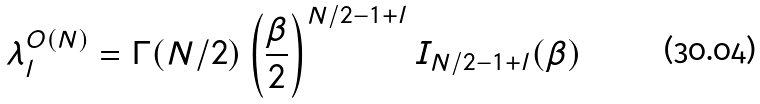<formula> <loc_0><loc_0><loc_500><loc_500>\lambda ^ { O ( N ) } _ { l } = \Gamma ( N / 2 ) \left ( \frac { \beta } { 2 } \right ) ^ { N / 2 - 1 + l } I _ { N / 2 - 1 + l } ( \beta )</formula> 